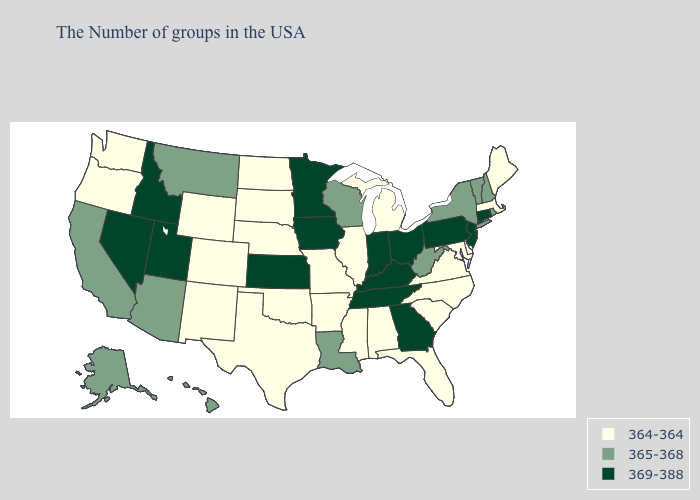What is the value of Pennsylvania?
Short answer required. 369-388. Name the states that have a value in the range 364-364?
Answer briefly. Maine, Massachusetts, Delaware, Maryland, Virginia, North Carolina, South Carolina, Florida, Michigan, Alabama, Illinois, Mississippi, Missouri, Arkansas, Nebraska, Oklahoma, Texas, South Dakota, North Dakota, Wyoming, Colorado, New Mexico, Washington, Oregon. Name the states that have a value in the range 365-368?
Keep it brief. Rhode Island, New Hampshire, Vermont, New York, West Virginia, Wisconsin, Louisiana, Montana, Arizona, California, Alaska, Hawaii. What is the lowest value in the MidWest?
Be succinct. 364-364. What is the highest value in the MidWest ?
Keep it brief. 369-388. Name the states that have a value in the range 369-388?
Quick response, please. Connecticut, New Jersey, Pennsylvania, Ohio, Georgia, Kentucky, Indiana, Tennessee, Minnesota, Iowa, Kansas, Utah, Idaho, Nevada. Does the first symbol in the legend represent the smallest category?
Answer briefly. Yes. Among the states that border Ohio , does Pennsylvania have the lowest value?
Concise answer only. No. Does the map have missing data?
Quick response, please. No. Does Nevada have the highest value in the USA?
Concise answer only. Yes. What is the highest value in the USA?
Answer briefly. 369-388. Which states have the lowest value in the South?
Be succinct. Delaware, Maryland, Virginia, North Carolina, South Carolina, Florida, Alabama, Mississippi, Arkansas, Oklahoma, Texas. Name the states that have a value in the range 364-364?
Write a very short answer. Maine, Massachusetts, Delaware, Maryland, Virginia, North Carolina, South Carolina, Florida, Michigan, Alabama, Illinois, Mississippi, Missouri, Arkansas, Nebraska, Oklahoma, Texas, South Dakota, North Dakota, Wyoming, Colorado, New Mexico, Washington, Oregon. Name the states that have a value in the range 369-388?
Write a very short answer. Connecticut, New Jersey, Pennsylvania, Ohio, Georgia, Kentucky, Indiana, Tennessee, Minnesota, Iowa, Kansas, Utah, Idaho, Nevada. Name the states that have a value in the range 365-368?
Keep it brief. Rhode Island, New Hampshire, Vermont, New York, West Virginia, Wisconsin, Louisiana, Montana, Arizona, California, Alaska, Hawaii. 